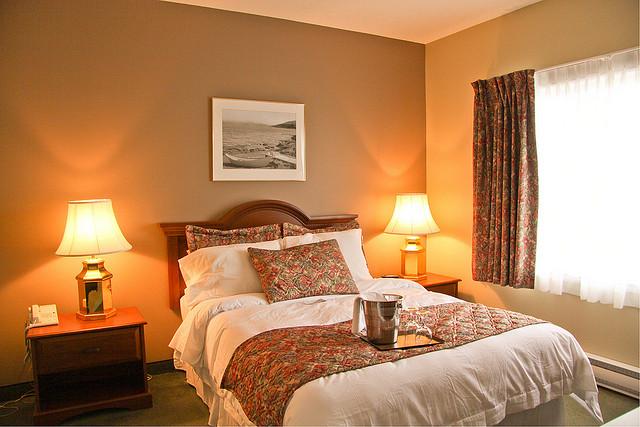Where are the two upside down glasses?
Quick response, please. On tray. Are the lights on?
Keep it brief. Yes. Is someone on the phone?
Quick response, please. No. 